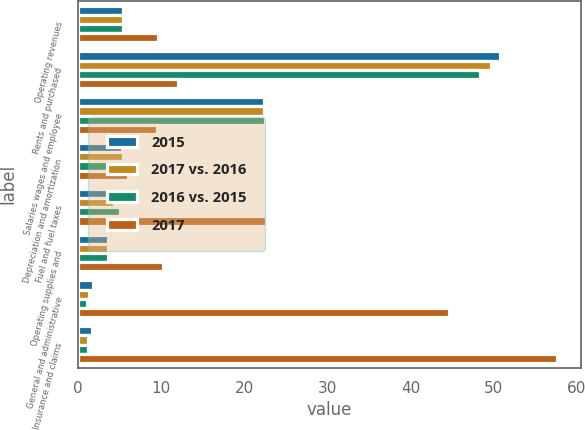Convert chart to OTSL. <chart><loc_0><loc_0><loc_500><loc_500><stacked_bar_chart><ecel><fcel>Operating revenues<fcel>Rents and purchased<fcel>Salaries wages and employee<fcel>Depreciation and amortization<fcel>Fuel and fuel taxes<fcel>Operating supplies and<fcel>General and administrative<fcel>Insurance and claims<nl><fcel>2015<fcel>5.5<fcel>50.8<fcel>22.4<fcel>5.3<fcel>4.8<fcel>3.6<fcel>1.8<fcel>1.7<nl><fcel>2017 vs. 2016<fcel>5.5<fcel>49.7<fcel>22.4<fcel>5.5<fcel>4.3<fcel>3.6<fcel>1.3<fcel>1.2<nl><fcel>2016 vs. 2015<fcel>5.5<fcel>48.4<fcel>22.5<fcel>5.5<fcel>5.1<fcel>3.6<fcel>1.1<fcel>1.2<nl><fcel>2017<fcel>9.7<fcel>12.1<fcel>9.5<fcel>6.1<fcel>22.6<fcel>10.3<fcel>44.6<fcel>57.6<nl></chart> 